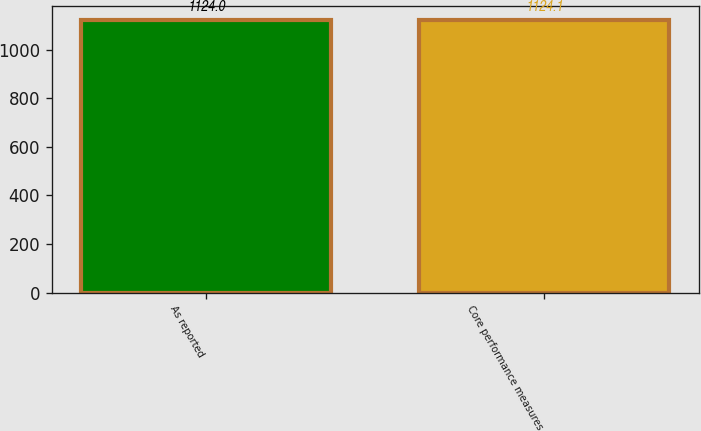Convert chart to OTSL. <chart><loc_0><loc_0><loc_500><loc_500><bar_chart><fcel>As reported<fcel>Core performance measures<nl><fcel>1124<fcel>1124.1<nl></chart> 